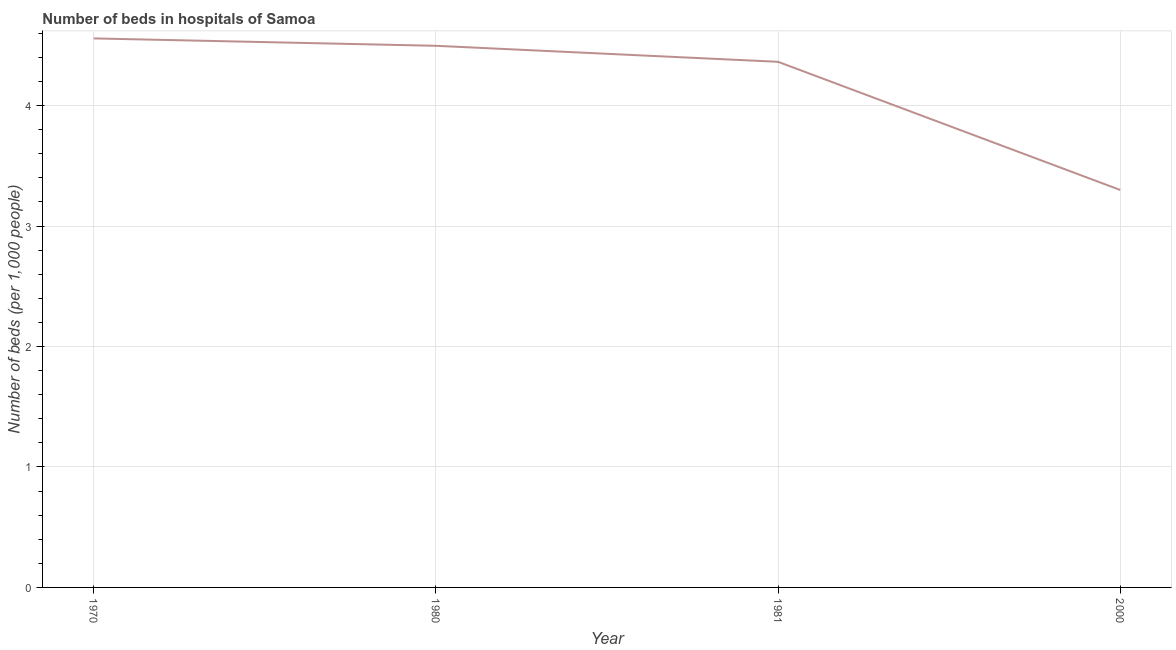What is the number of hospital beds in 2000?
Ensure brevity in your answer.  3.3. Across all years, what is the maximum number of hospital beds?
Keep it short and to the point. 4.56. Across all years, what is the minimum number of hospital beds?
Ensure brevity in your answer.  3.3. In which year was the number of hospital beds maximum?
Ensure brevity in your answer.  1970. What is the sum of the number of hospital beds?
Provide a short and direct response. 16.72. What is the difference between the number of hospital beds in 1970 and 1981?
Offer a terse response. 0.19. What is the average number of hospital beds per year?
Offer a terse response. 4.18. What is the median number of hospital beds?
Provide a succinct answer. 4.43. What is the ratio of the number of hospital beds in 1970 to that in 1980?
Provide a short and direct response. 1.01. Is the number of hospital beds in 1980 less than that in 1981?
Your response must be concise. No. Is the difference between the number of hospital beds in 1970 and 1980 greater than the difference between any two years?
Keep it short and to the point. No. What is the difference between the highest and the second highest number of hospital beds?
Make the answer very short. 0.06. Is the sum of the number of hospital beds in 1970 and 1981 greater than the maximum number of hospital beds across all years?
Provide a succinct answer. Yes. What is the difference between the highest and the lowest number of hospital beds?
Ensure brevity in your answer.  1.26. In how many years, is the number of hospital beds greater than the average number of hospital beds taken over all years?
Offer a terse response. 3. How many years are there in the graph?
Your answer should be compact. 4. What is the difference between two consecutive major ticks on the Y-axis?
Give a very brief answer. 1. Are the values on the major ticks of Y-axis written in scientific E-notation?
Ensure brevity in your answer.  No. Does the graph contain grids?
Provide a succinct answer. Yes. What is the title of the graph?
Offer a terse response. Number of beds in hospitals of Samoa. What is the label or title of the Y-axis?
Give a very brief answer. Number of beds (per 1,0 people). What is the Number of beds (per 1,000 people) of 1970?
Provide a succinct answer. 4.56. What is the Number of beds (per 1,000 people) of 1980?
Keep it short and to the point. 4.5. What is the Number of beds (per 1,000 people) in 1981?
Provide a succinct answer. 4.36. What is the Number of beds (per 1,000 people) in 2000?
Offer a very short reply. 3.3. What is the difference between the Number of beds (per 1,000 people) in 1970 and 1980?
Your response must be concise. 0.06. What is the difference between the Number of beds (per 1,000 people) in 1970 and 1981?
Give a very brief answer. 0.19. What is the difference between the Number of beds (per 1,000 people) in 1970 and 2000?
Provide a succinct answer. 1.26. What is the difference between the Number of beds (per 1,000 people) in 1980 and 1981?
Provide a succinct answer. 0.13. What is the difference between the Number of beds (per 1,000 people) in 1980 and 2000?
Provide a succinct answer. 1.2. What is the difference between the Number of beds (per 1,000 people) in 1981 and 2000?
Ensure brevity in your answer.  1.06. What is the ratio of the Number of beds (per 1,000 people) in 1970 to that in 1981?
Ensure brevity in your answer.  1.04. What is the ratio of the Number of beds (per 1,000 people) in 1970 to that in 2000?
Provide a short and direct response. 1.38. What is the ratio of the Number of beds (per 1,000 people) in 1980 to that in 1981?
Provide a succinct answer. 1.03. What is the ratio of the Number of beds (per 1,000 people) in 1980 to that in 2000?
Provide a succinct answer. 1.36. What is the ratio of the Number of beds (per 1,000 people) in 1981 to that in 2000?
Offer a terse response. 1.32. 